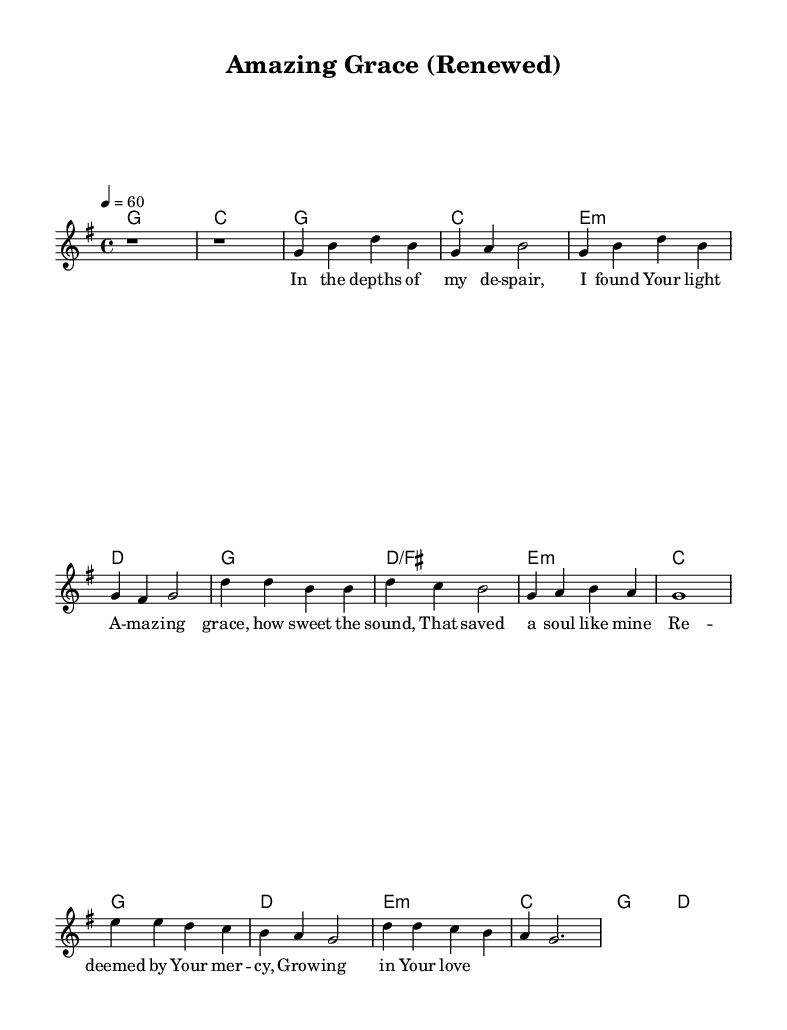What is the key signature of this music? The key signature is G major, which has one sharp (F#).
Answer: G major What is the time signature of this music? The time signature is 4/4, indicating four beats per measure.
Answer: 4/4 What is the tempo marking of this music? The tempo marking is quarter note equals 60 beats per minute.
Answer: 60 How many bars are there in the chorus section? The chorus consists of four bars as indicated by the grouping and the structure laid out in the score.
Answer: 4 What is the primary theme expressed in the lyrics? The lyrics express themes of faith, redemption, and spiritual growth, highlighting personal experiences of grace and mercy.
Answer: Faith and redemption What is the chord progression for the first verse? The chord progression for the first verse is G, C, E minor, D. This sequence underpins the melody for the verse.
Answer: G, C, E minor, D What stylistic elements are present in this Rhythm and Blues ballad? The song incorporates heartfelt lyrics, soulful melodies, and a reflective tone, typical of Contemporary R&B ballads emphasizing emotional experiences.
Answer: Heartfelt lyrics and soulful melodies 